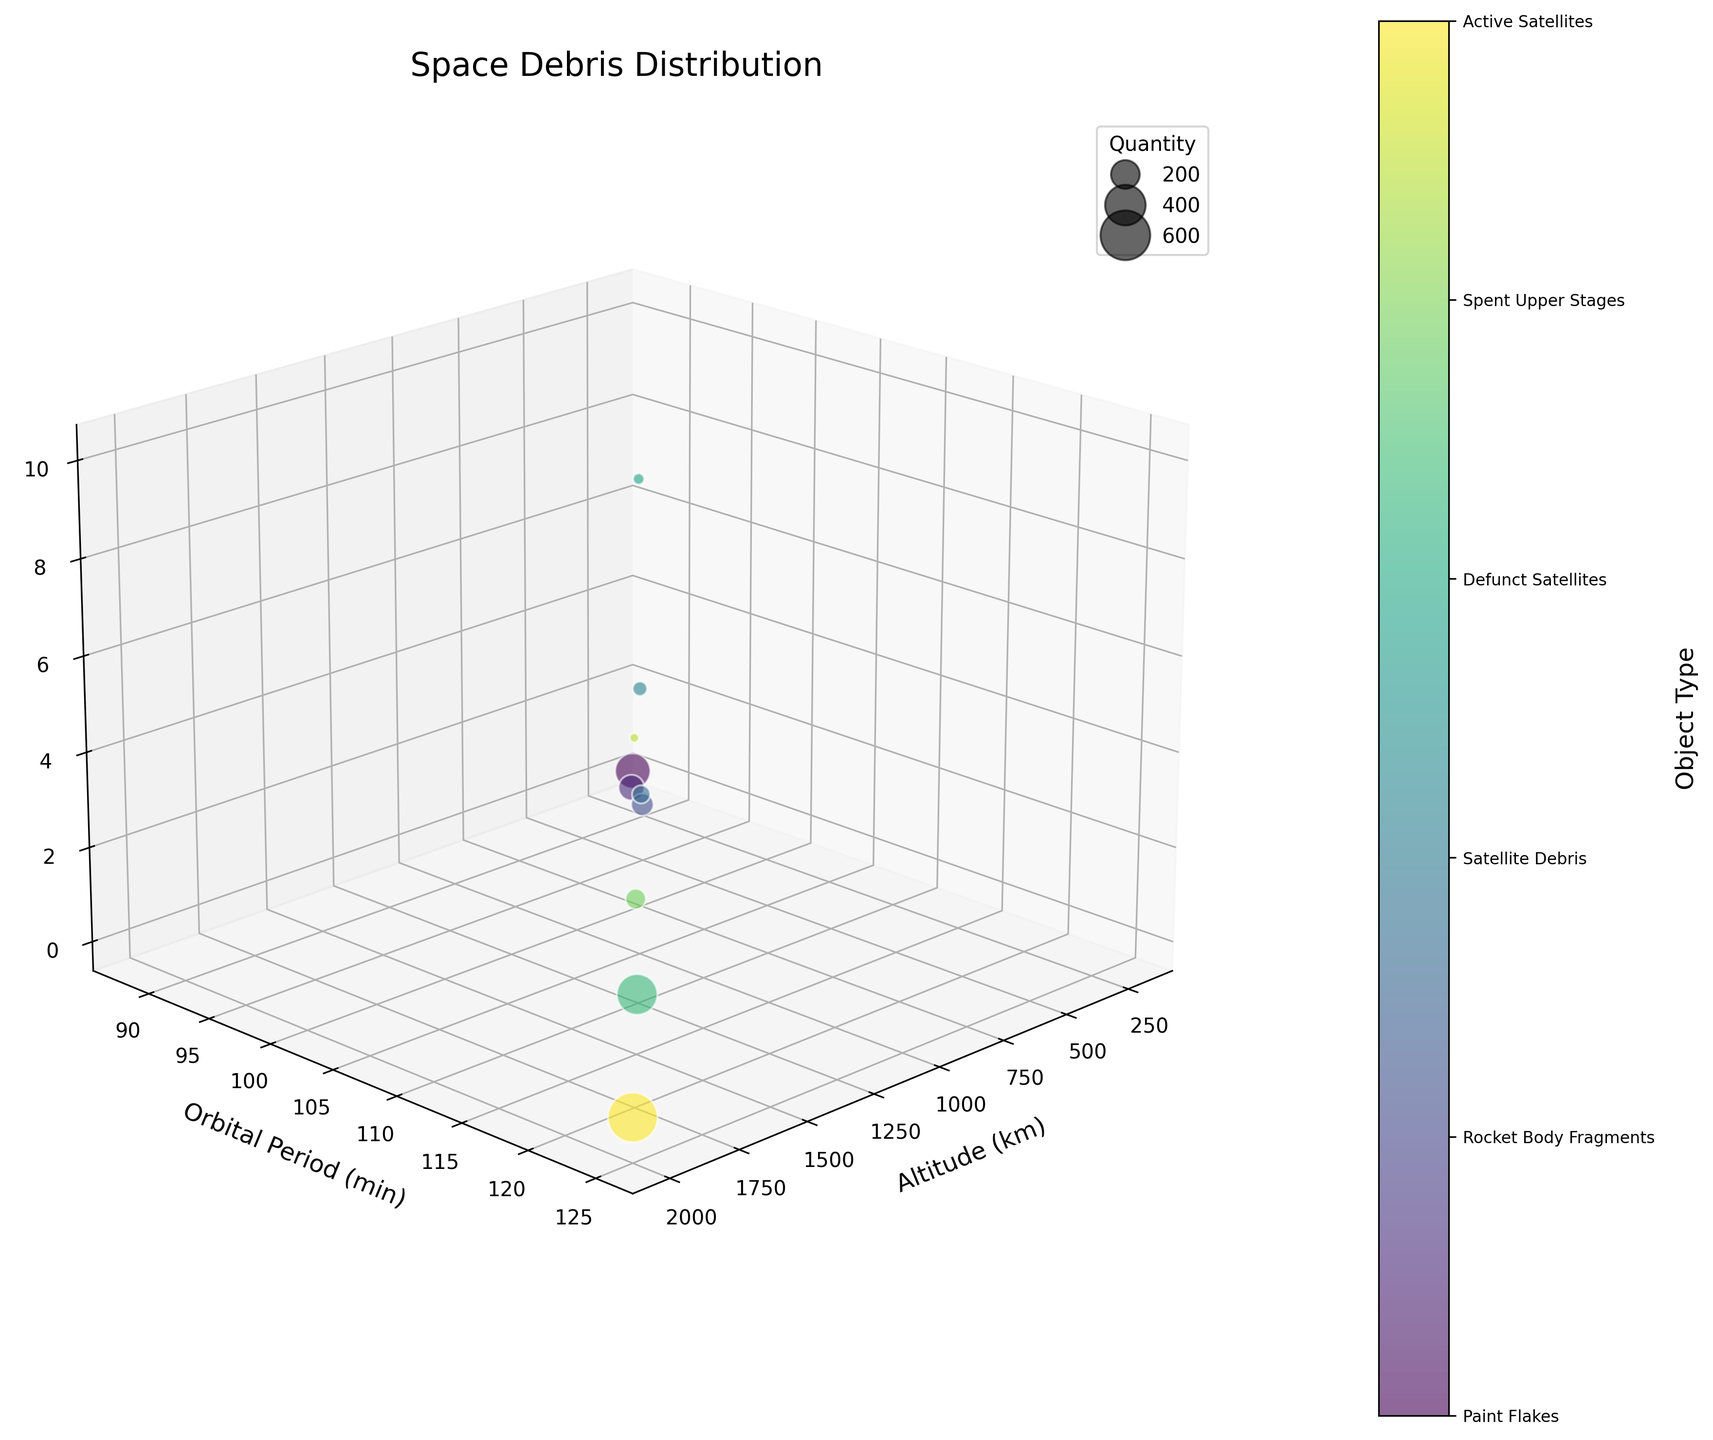What is the title of the chart? The title is usually placed at the top of the chart. By looking at the chart, you can see the title is "Space Debris Distribution".
Answer: Space Debris Distribution How many object types are displayed in the chart? By examining the color bar and the labels along the color bar, we can identify the different object types. Each type is distinct based on color and label.
Answer: 10 Which object type has the highest quantity? Identify the largest bubbles in the chart, then refer to the corresponding color and label in the bubble size legend. The largest bubbles correspond to "Micrometeorites" with a quantity of 300.
Answer: Micrometeorites What are the axes labels in the chart? Look at the labels along each of the three axes: the x-axis, y-axis, and z-axis. The x-axis is "Altitude (km)", the y-axis is "Orbital Period (min)", and the z-axis is "Size (m)".
Answer: Altitude (km), Orbital Period (min), Size (m) At what altitude do defunct satellites have the greatest size? Locate the bubble labeled "Defunct Satellites" and identify its position along the x-axis, which represents altitude, and the z-axis, which represents size.
Answer: 800 km Which object type has the smallest average size? Look at the bubbles and their corresponding positions on the z-axis (size). "Paint Flakes" have the smallest average size, as their bubbles are near the lower end of the z-axis.
Answer: Paint Flakes How does the orbital period change with altitude for paint flakes? Look for the bubbles corresponding to "Paint Flakes" and observe their vertical position along the y-axis (orbital period). Compare how this position changes as you move horizontally along the x-axis (altitude).
Answer: Increases Between "Satellite Debris" and "Solar Panel Fragments", which has a larger average size? Compare the positions of the bubbles for "Satellite Debris" and "Solar Panel Fragments" on the z-axis (size). Solar Panel Fragments have larger average sizes.
Answer: Solar Panel Fragments Which object types are found at an altitude of 1200 km? Identify the bubbles located at 1200 km along the x-axis (altitude) and read their labels. "Active Satellites" are found at this altitude.
Answer: Active Satellites What is the approximate orbital period for an object with a size of 7.0 m? Locate the bubble with a size of 7.0 m on the z-axis and trace its vertical positioning to the y-axis to find the corresponding orbital period.
Answer: 121 min 